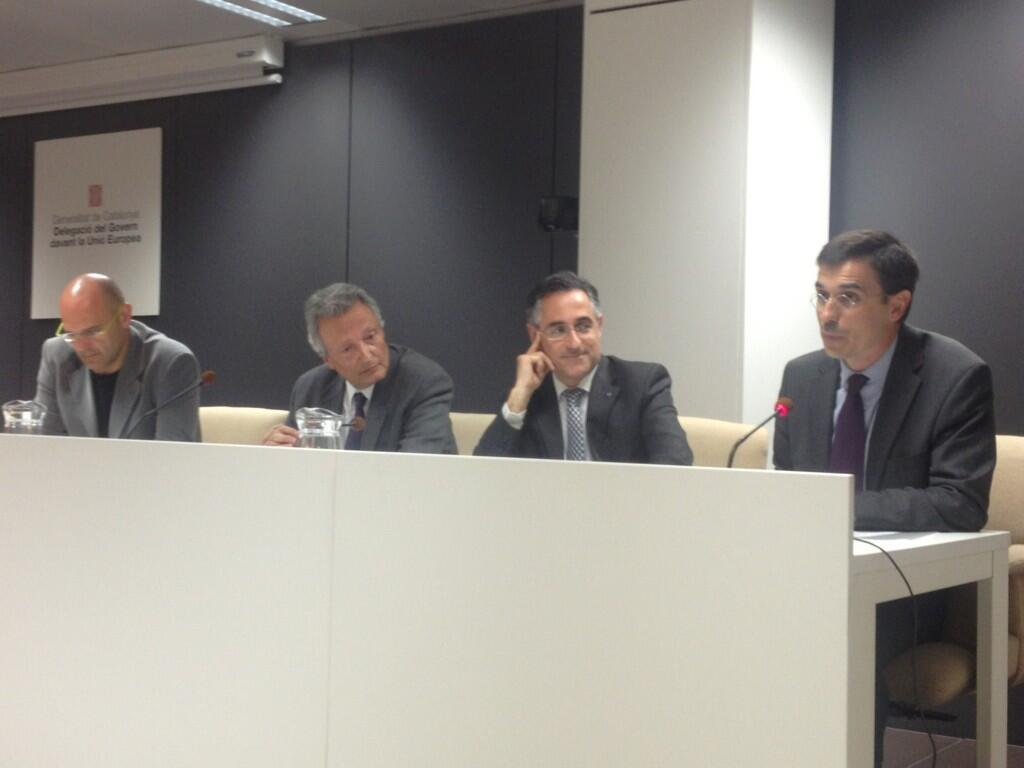What color are the dresses worn by the people in the image? The people are wearing black color dresses in the image. What are the people doing in the image? The people are sitting on chairs. What can be seen in the background of the image? There is a wall in the image. What is hanging on the wall? There is a banner in the image. What is present on the table in the image? There is a table in the image with mugs on it. Can you see any stamps on the mugs in the image? There is no mention of stamps on the mugs in the image; the facts only mention that there are mugs on the table. 